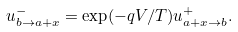Convert formula to latex. <formula><loc_0><loc_0><loc_500><loc_500>u ^ { - } _ { b \rightarrow a + x } = \exp ( - q V / T ) u ^ { + } _ { a + x \rightarrow b } .</formula> 